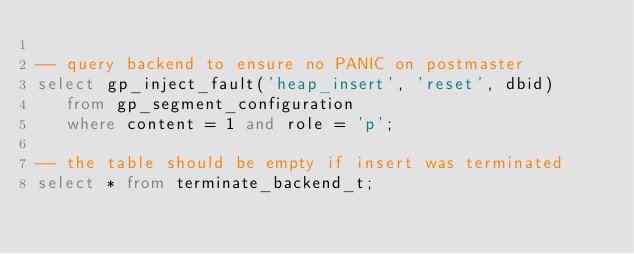Convert code to text. <code><loc_0><loc_0><loc_500><loc_500><_SQL_>
-- query backend to ensure no PANIC on postmaster
select gp_inject_fault('heap_insert', 'reset', dbid)
   from gp_segment_configuration
   where content = 1 and role = 'p';

-- the table should be empty if insert was terminated
select * from terminate_backend_t;
</code> 